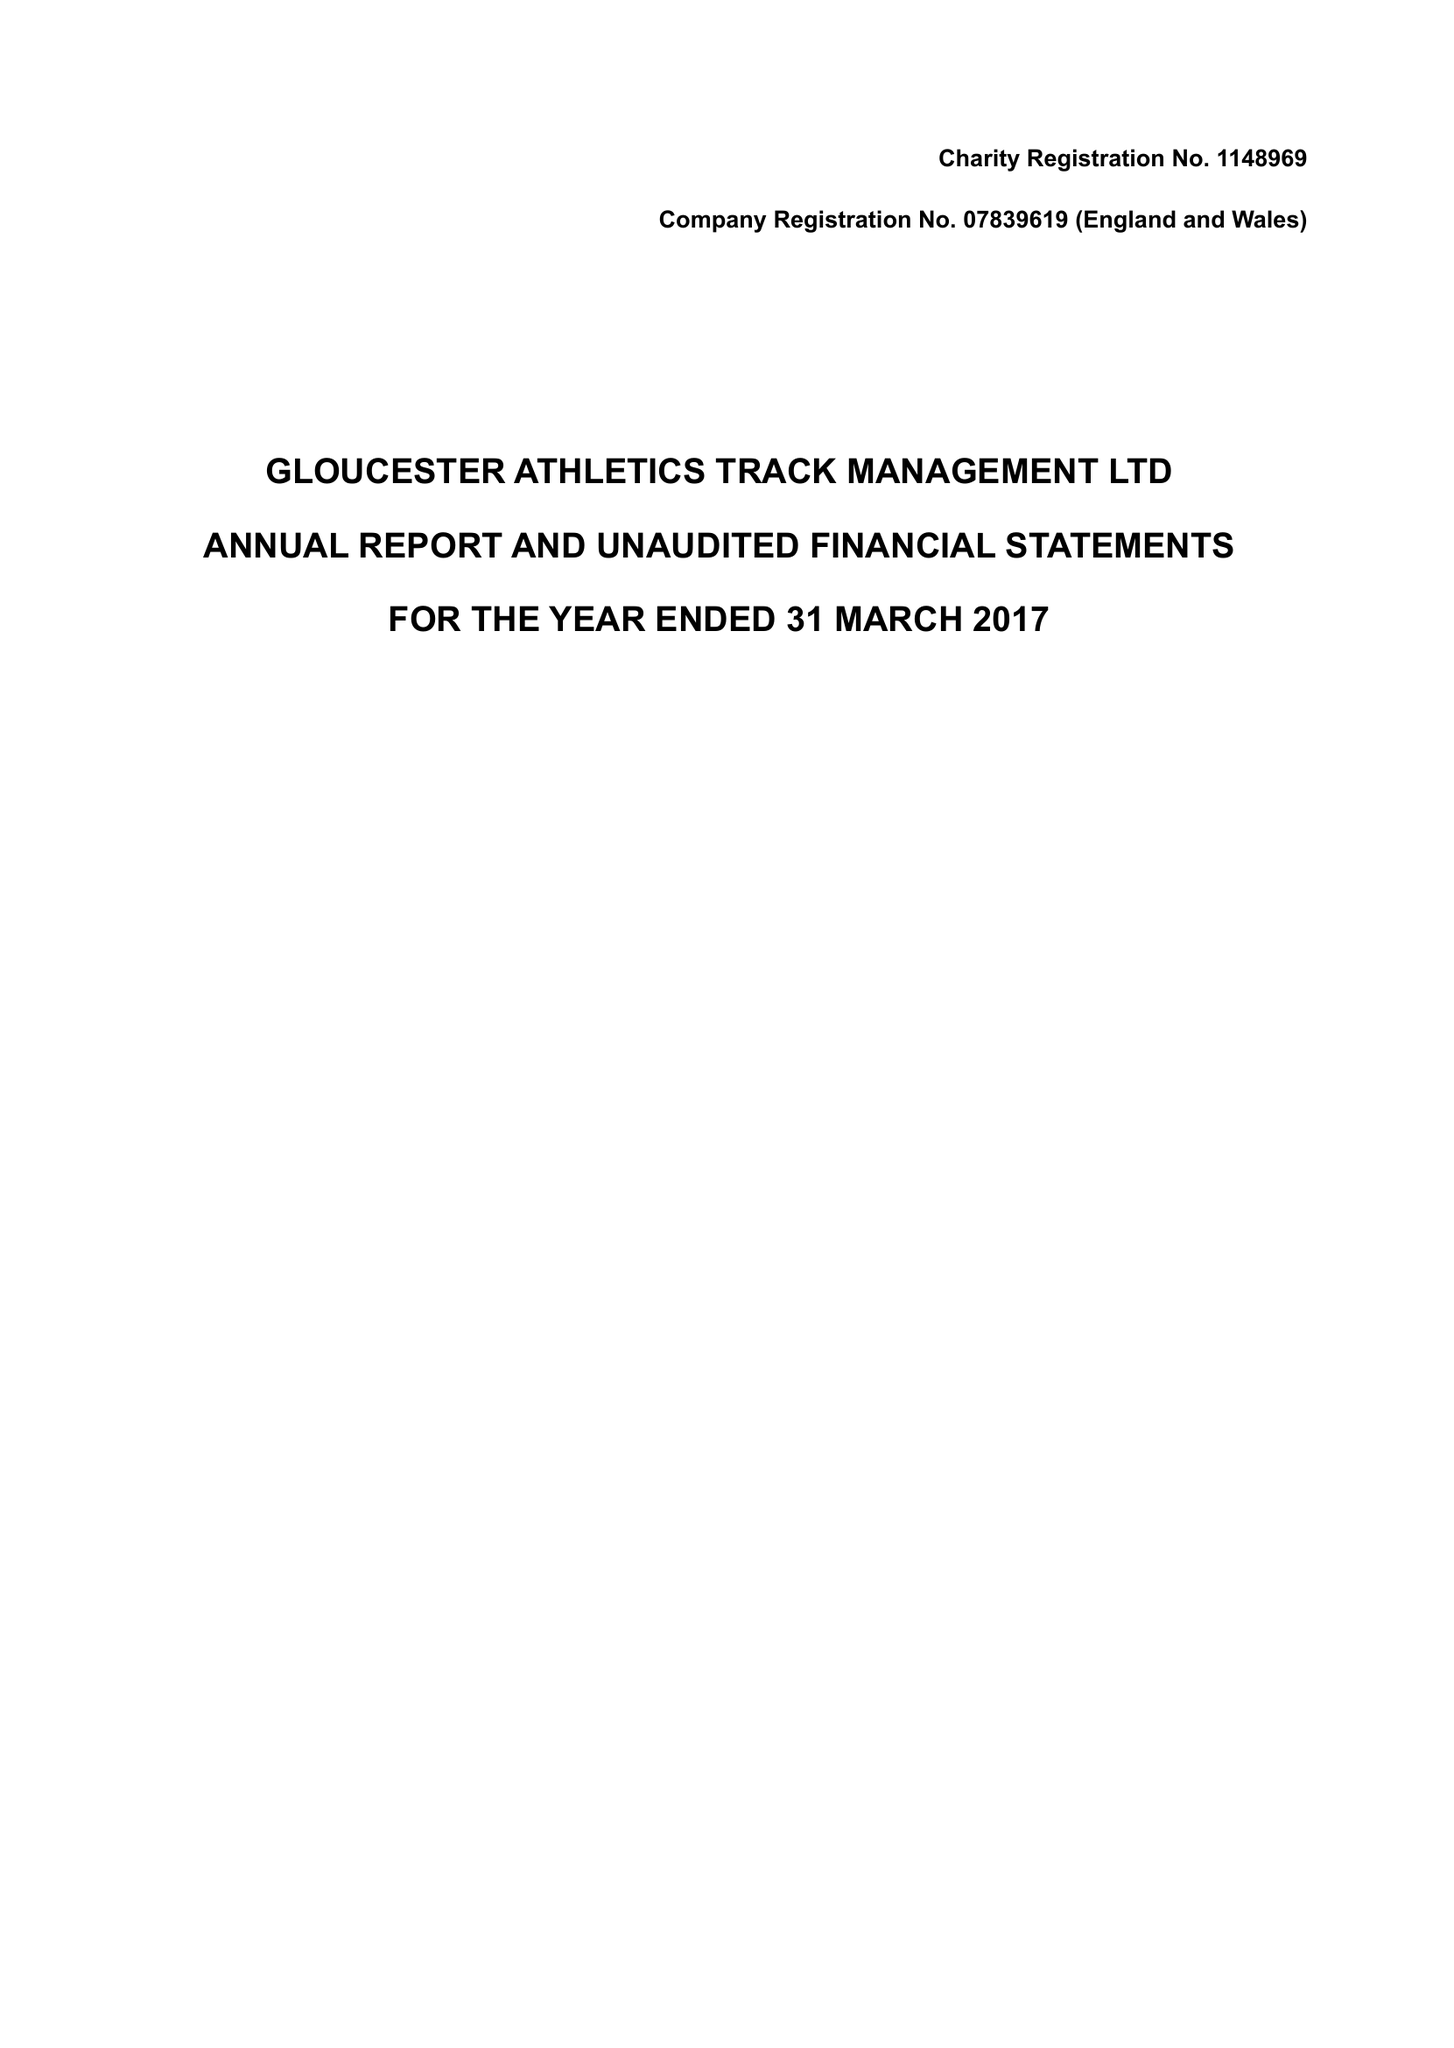What is the value for the charity_name?
Answer the question using a single word or phrase. Gloucester Athletics Track Management Ltd. 